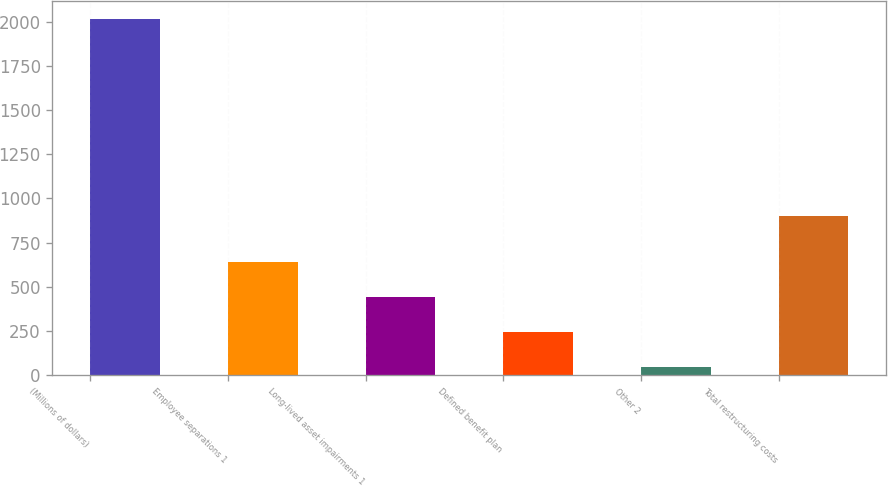Convert chart. <chart><loc_0><loc_0><loc_500><loc_500><bar_chart><fcel>(Millions of dollars)<fcel>Employee separations 1<fcel>Long-lived asset impairments 1<fcel>Defined benefit plan<fcel>Other 2<fcel>Total restructuring costs<nl><fcel>2015<fcel>641<fcel>441.4<fcel>244.7<fcel>48<fcel>898<nl></chart> 